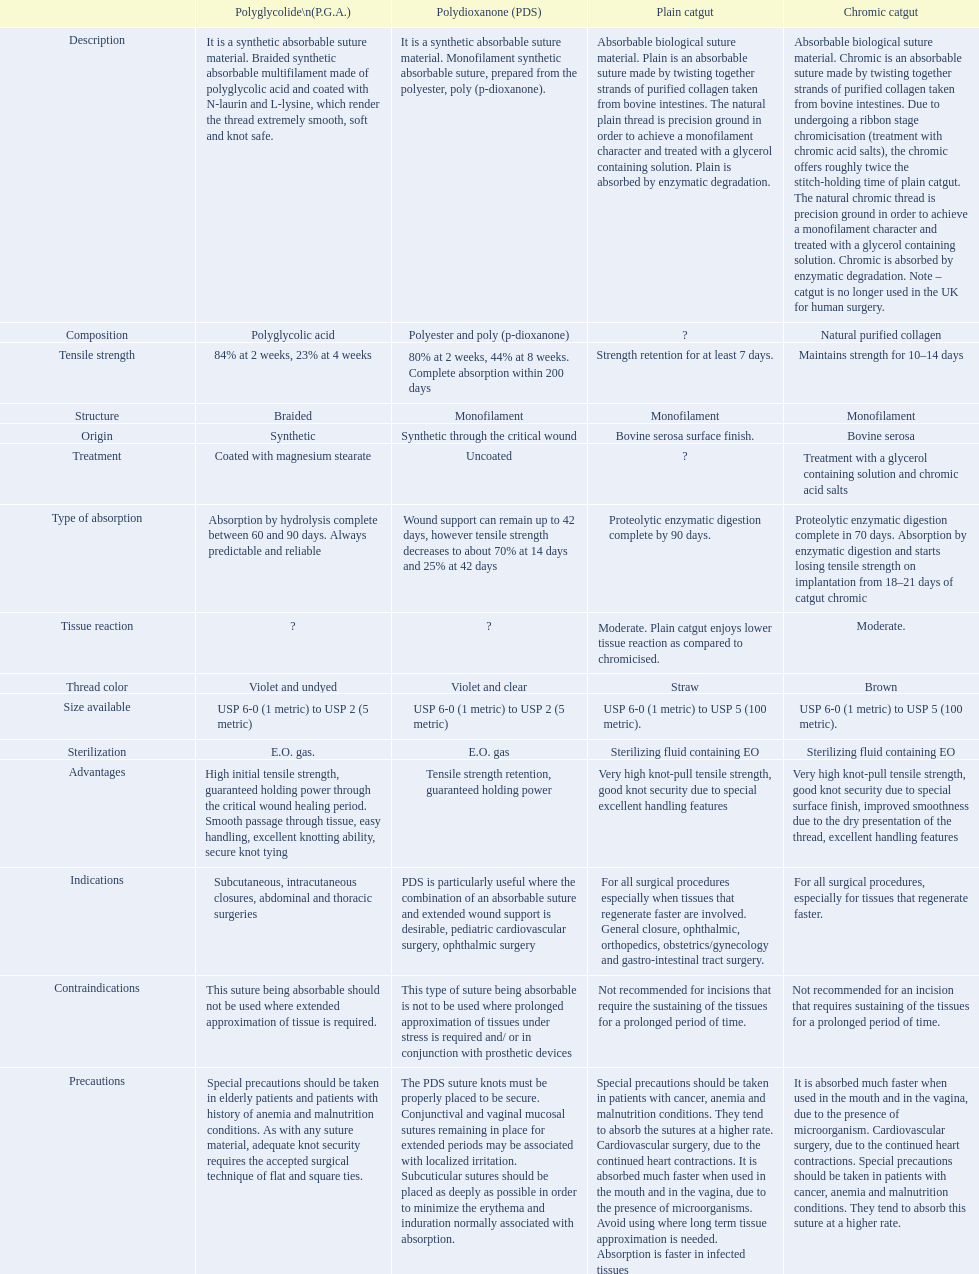Would you be able to parse every entry in this table? {'header': ['', 'Polyglycolide\\n(P.G.A.)', 'Polydioxanone (PDS)', 'Plain catgut', 'Chromic catgut'], 'rows': [['Description', 'It is a synthetic absorbable suture material. Braided synthetic absorbable multifilament made of polyglycolic acid and coated with N-laurin and L-lysine, which render the thread extremely smooth, soft and knot safe.', 'It is a synthetic absorbable suture material. Monofilament synthetic absorbable suture, prepared from the polyester, poly (p-dioxanone).', 'Absorbable biological suture material. Plain is an absorbable suture made by twisting together strands of purified collagen taken from bovine intestines. The natural plain thread is precision ground in order to achieve a monofilament character and treated with a glycerol containing solution. Plain is absorbed by enzymatic degradation.', 'Absorbable biological suture material. Chromic is an absorbable suture made by twisting together strands of purified collagen taken from bovine intestines. Due to undergoing a ribbon stage chromicisation (treatment with chromic acid salts), the chromic offers roughly twice the stitch-holding time of plain catgut. The natural chromic thread is precision ground in order to achieve a monofilament character and treated with a glycerol containing solution. Chromic is absorbed by enzymatic degradation. Note – catgut is no longer used in the UK for human surgery.'], ['Composition', 'Polyglycolic acid', 'Polyester and poly (p-dioxanone)', '?', 'Natural purified collagen'], ['Tensile strength', '84% at 2 weeks, 23% at 4 weeks', '80% at 2 weeks, 44% at 8 weeks. Complete absorption within 200 days', 'Strength retention for at least 7 days.', 'Maintains strength for 10–14 days'], ['Structure', 'Braided', 'Monofilament', 'Monofilament', 'Monofilament'], ['Origin', 'Synthetic', 'Synthetic through the critical wound', 'Bovine serosa surface finish.', 'Bovine serosa'], ['Treatment', 'Coated with magnesium stearate', 'Uncoated', '?', 'Treatment with a glycerol containing solution and chromic acid salts'], ['Type of absorption', 'Absorption by hydrolysis complete between 60 and 90 days. Always predictable and reliable', 'Wound support can remain up to 42 days, however tensile strength decreases to about 70% at 14 days and 25% at 42 days', 'Proteolytic enzymatic digestion complete by 90 days.', 'Proteolytic enzymatic digestion complete in 70 days. Absorption by enzymatic digestion and starts losing tensile strength on implantation from 18–21 days of catgut chromic'], ['Tissue reaction', '?', '?', 'Moderate. Plain catgut enjoys lower tissue reaction as compared to chromicised.', 'Moderate.'], ['Thread color', 'Violet and undyed', 'Violet and clear', 'Straw', 'Brown'], ['Size available', 'USP 6-0 (1 metric) to USP 2 (5 metric)', 'USP 6-0 (1 metric) to USP 2 (5 metric)', 'USP 6-0 (1 metric) to USP 5 (100 metric).', 'USP 6-0 (1 metric) to USP 5 (100 metric).'], ['Sterilization', 'E.O. gas.', 'E.O. gas', 'Sterilizing fluid containing EO', 'Sterilizing fluid containing EO'], ['Advantages', 'High initial tensile strength, guaranteed holding power through the critical wound healing period. Smooth passage through tissue, easy handling, excellent knotting ability, secure knot tying', 'Tensile strength retention, guaranteed holding power', 'Very high knot-pull tensile strength, good knot security due to special excellent handling features', 'Very high knot-pull tensile strength, good knot security due to special surface finish, improved smoothness due to the dry presentation of the thread, excellent handling features'], ['Indications', 'Subcutaneous, intracutaneous closures, abdominal and thoracic surgeries', 'PDS is particularly useful where the combination of an absorbable suture and extended wound support is desirable, pediatric cardiovascular surgery, ophthalmic surgery', 'For all surgical procedures especially when tissues that regenerate faster are involved. General closure, ophthalmic, orthopedics, obstetrics/gynecology and gastro-intestinal tract surgery.', 'For all surgical procedures, especially for tissues that regenerate faster.'], ['Contraindications', 'This suture being absorbable should not be used where extended approximation of tissue is required.', 'This type of suture being absorbable is not to be used where prolonged approximation of tissues under stress is required and/ or in conjunction with prosthetic devices', 'Not recommended for incisions that require the sustaining of the tissues for a prolonged period of time.', 'Not recommended for an incision that requires sustaining of the tissues for a prolonged period of time.'], ['Precautions', 'Special precautions should be taken in elderly patients and patients with history of anemia and malnutrition conditions. As with any suture material, adequate knot security requires the accepted surgical technique of flat and square ties.', 'The PDS suture knots must be properly placed to be secure. Conjunctival and vaginal mucosal sutures remaining in place for extended periods may be associated with localized irritation. Subcuticular sutures should be placed as deeply as possible in order to minimize the erythema and induration normally associated with absorption.', 'Special precautions should be taken in patients with cancer, anemia and malnutrition conditions. They tend to absorb the sutures at a higher rate. Cardiovascular surgery, due to the continued heart contractions. It is absorbed much faster when used in the mouth and in the vagina, due to the presence of microorganisms. Avoid using where long term tissue approximation is needed. Absorption is faster in infected tissues', 'It is absorbed much faster when used in the mouth and in the vagina, due to the presence of microorganism. Cardiovascular surgery, due to the continued heart contractions. Special precautions should be taken in patients with cancer, anemia and malnutrition conditions. They tend to absorb this suture at a higher rate.']]} What categories are listed in the suture materials comparison chart? Description, Composition, Tensile strength, Structure, Origin, Treatment, Type of absorption, Tissue reaction, Thread color, Size available, Sterilization, Advantages, Indications, Contraindications, Precautions. Of the testile strength, which is the lowest? Strength retention for at least 7 days. 